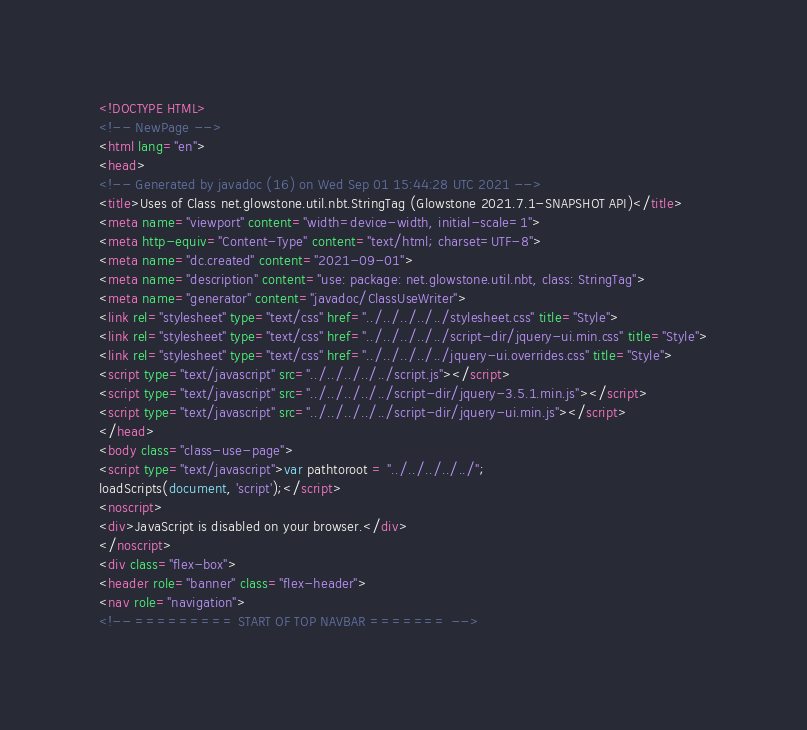<code> <loc_0><loc_0><loc_500><loc_500><_HTML_><!DOCTYPE HTML>
<!-- NewPage -->
<html lang="en">
<head>
<!-- Generated by javadoc (16) on Wed Sep 01 15:44:28 UTC 2021 -->
<title>Uses of Class net.glowstone.util.nbt.StringTag (Glowstone 2021.7.1-SNAPSHOT API)</title>
<meta name="viewport" content="width=device-width, initial-scale=1">
<meta http-equiv="Content-Type" content="text/html; charset=UTF-8">
<meta name="dc.created" content="2021-09-01">
<meta name="description" content="use: package: net.glowstone.util.nbt, class: StringTag">
<meta name="generator" content="javadoc/ClassUseWriter">
<link rel="stylesheet" type="text/css" href="../../../../../stylesheet.css" title="Style">
<link rel="stylesheet" type="text/css" href="../../../../../script-dir/jquery-ui.min.css" title="Style">
<link rel="stylesheet" type="text/css" href="../../../../../jquery-ui.overrides.css" title="Style">
<script type="text/javascript" src="../../../../../script.js"></script>
<script type="text/javascript" src="../../../../../script-dir/jquery-3.5.1.min.js"></script>
<script type="text/javascript" src="../../../../../script-dir/jquery-ui.min.js"></script>
</head>
<body class="class-use-page">
<script type="text/javascript">var pathtoroot = "../../../../../";
loadScripts(document, 'script');</script>
<noscript>
<div>JavaScript is disabled on your browser.</div>
</noscript>
<div class="flex-box">
<header role="banner" class="flex-header">
<nav role="navigation">
<!-- ========= START OF TOP NAVBAR ======= --></code> 